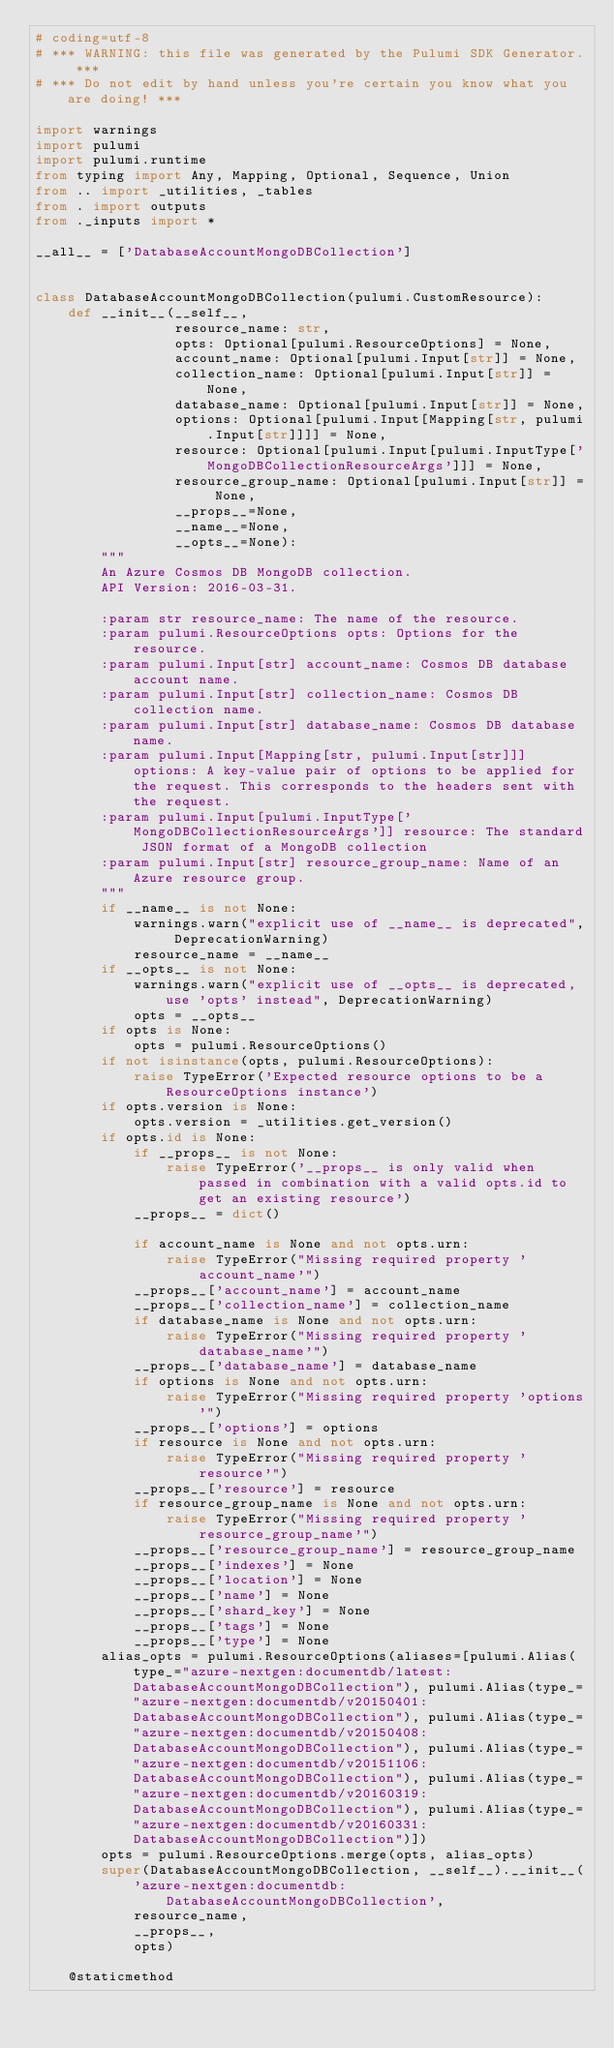<code> <loc_0><loc_0><loc_500><loc_500><_Python_># coding=utf-8
# *** WARNING: this file was generated by the Pulumi SDK Generator. ***
# *** Do not edit by hand unless you're certain you know what you are doing! ***

import warnings
import pulumi
import pulumi.runtime
from typing import Any, Mapping, Optional, Sequence, Union
from .. import _utilities, _tables
from . import outputs
from ._inputs import *

__all__ = ['DatabaseAccountMongoDBCollection']


class DatabaseAccountMongoDBCollection(pulumi.CustomResource):
    def __init__(__self__,
                 resource_name: str,
                 opts: Optional[pulumi.ResourceOptions] = None,
                 account_name: Optional[pulumi.Input[str]] = None,
                 collection_name: Optional[pulumi.Input[str]] = None,
                 database_name: Optional[pulumi.Input[str]] = None,
                 options: Optional[pulumi.Input[Mapping[str, pulumi.Input[str]]]] = None,
                 resource: Optional[pulumi.Input[pulumi.InputType['MongoDBCollectionResourceArgs']]] = None,
                 resource_group_name: Optional[pulumi.Input[str]] = None,
                 __props__=None,
                 __name__=None,
                 __opts__=None):
        """
        An Azure Cosmos DB MongoDB collection.
        API Version: 2016-03-31.

        :param str resource_name: The name of the resource.
        :param pulumi.ResourceOptions opts: Options for the resource.
        :param pulumi.Input[str] account_name: Cosmos DB database account name.
        :param pulumi.Input[str] collection_name: Cosmos DB collection name.
        :param pulumi.Input[str] database_name: Cosmos DB database name.
        :param pulumi.Input[Mapping[str, pulumi.Input[str]]] options: A key-value pair of options to be applied for the request. This corresponds to the headers sent with the request.
        :param pulumi.Input[pulumi.InputType['MongoDBCollectionResourceArgs']] resource: The standard JSON format of a MongoDB collection
        :param pulumi.Input[str] resource_group_name: Name of an Azure resource group.
        """
        if __name__ is not None:
            warnings.warn("explicit use of __name__ is deprecated", DeprecationWarning)
            resource_name = __name__
        if __opts__ is not None:
            warnings.warn("explicit use of __opts__ is deprecated, use 'opts' instead", DeprecationWarning)
            opts = __opts__
        if opts is None:
            opts = pulumi.ResourceOptions()
        if not isinstance(opts, pulumi.ResourceOptions):
            raise TypeError('Expected resource options to be a ResourceOptions instance')
        if opts.version is None:
            opts.version = _utilities.get_version()
        if opts.id is None:
            if __props__ is not None:
                raise TypeError('__props__ is only valid when passed in combination with a valid opts.id to get an existing resource')
            __props__ = dict()

            if account_name is None and not opts.urn:
                raise TypeError("Missing required property 'account_name'")
            __props__['account_name'] = account_name
            __props__['collection_name'] = collection_name
            if database_name is None and not opts.urn:
                raise TypeError("Missing required property 'database_name'")
            __props__['database_name'] = database_name
            if options is None and not opts.urn:
                raise TypeError("Missing required property 'options'")
            __props__['options'] = options
            if resource is None and not opts.urn:
                raise TypeError("Missing required property 'resource'")
            __props__['resource'] = resource
            if resource_group_name is None and not opts.urn:
                raise TypeError("Missing required property 'resource_group_name'")
            __props__['resource_group_name'] = resource_group_name
            __props__['indexes'] = None
            __props__['location'] = None
            __props__['name'] = None
            __props__['shard_key'] = None
            __props__['tags'] = None
            __props__['type'] = None
        alias_opts = pulumi.ResourceOptions(aliases=[pulumi.Alias(type_="azure-nextgen:documentdb/latest:DatabaseAccountMongoDBCollection"), pulumi.Alias(type_="azure-nextgen:documentdb/v20150401:DatabaseAccountMongoDBCollection"), pulumi.Alias(type_="azure-nextgen:documentdb/v20150408:DatabaseAccountMongoDBCollection"), pulumi.Alias(type_="azure-nextgen:documentdb/v20151106:DatabaseAccountMongoDBCollection"), pulumi.Alias(type_="azure-nextgen:documentdb/v20160319:DatabaseAccountMongoDBCollection"), pulumi.Alias(type_="azure-nextgen:documentdb/v20160331:DatabaseAccountMongoDBCollection")])
        opts = pulumi.ResourceOptions.merge(opts, alias_opts)
        super(DatabaseAccountMongoDBCollection, __self__).__init__(
            'azure-nextgen:documentdb:DatabaseAccountMongoDBCollection',
            resource_name,
            __props__,
            opts)

    @staticmethod</code> 